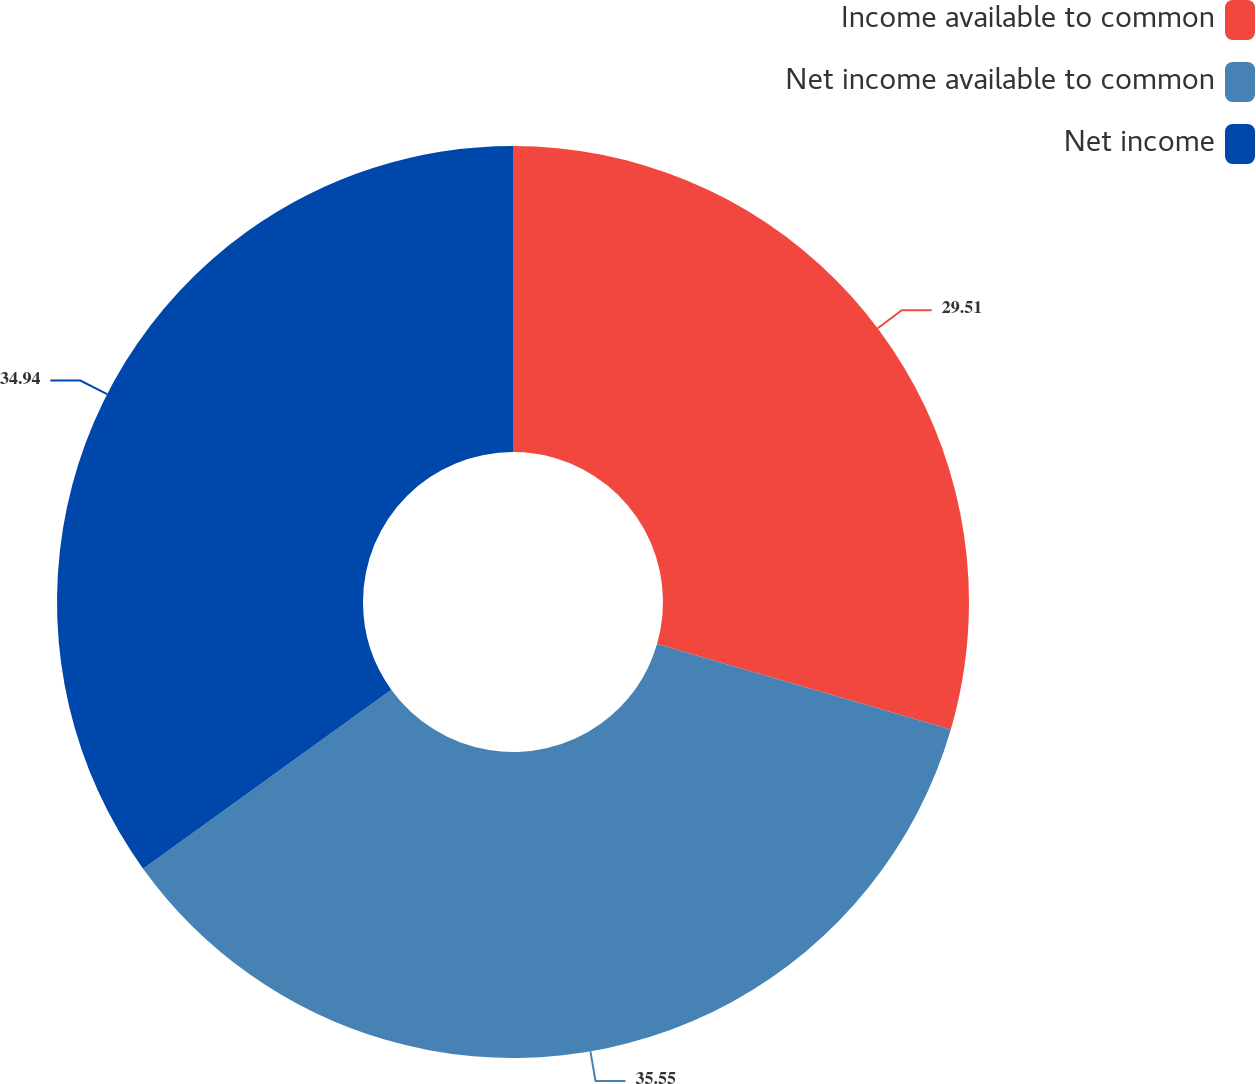<chart> <loc_0><loc_0><loc_500><loc_500><pie_chart><fcel>Income available to common<fcel>Net income available to common<fcel>Net income<nl><fcel>29.51%<fcel>35.55%<fcel>34.94%<nl></chart> 